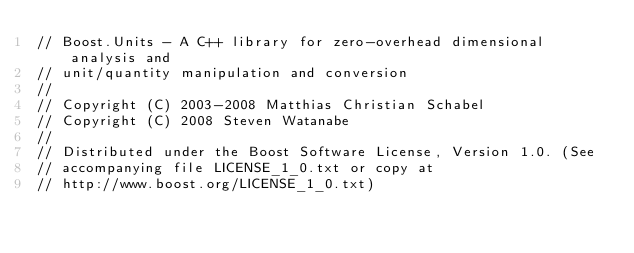Convert code to text. <code><loc_0><loc_0><loc_500><loc_500><_C++_>// Boost.Units - A C++ library for zero-overhead dimensional analysis and 
// unit/quantity manipulation and conversion
//
// Copyright (C) 2003-2008 Matthias Christian Schabel
// Copyright (C) 2008 Steven Watanabe
//
// Distributed under the Boost Software License, Version 1.0. (See
// accompanying file LICENSE_1_0.txt or copy at
// http://www.boost.org/LICENSE_1_0.txt)
</code> 